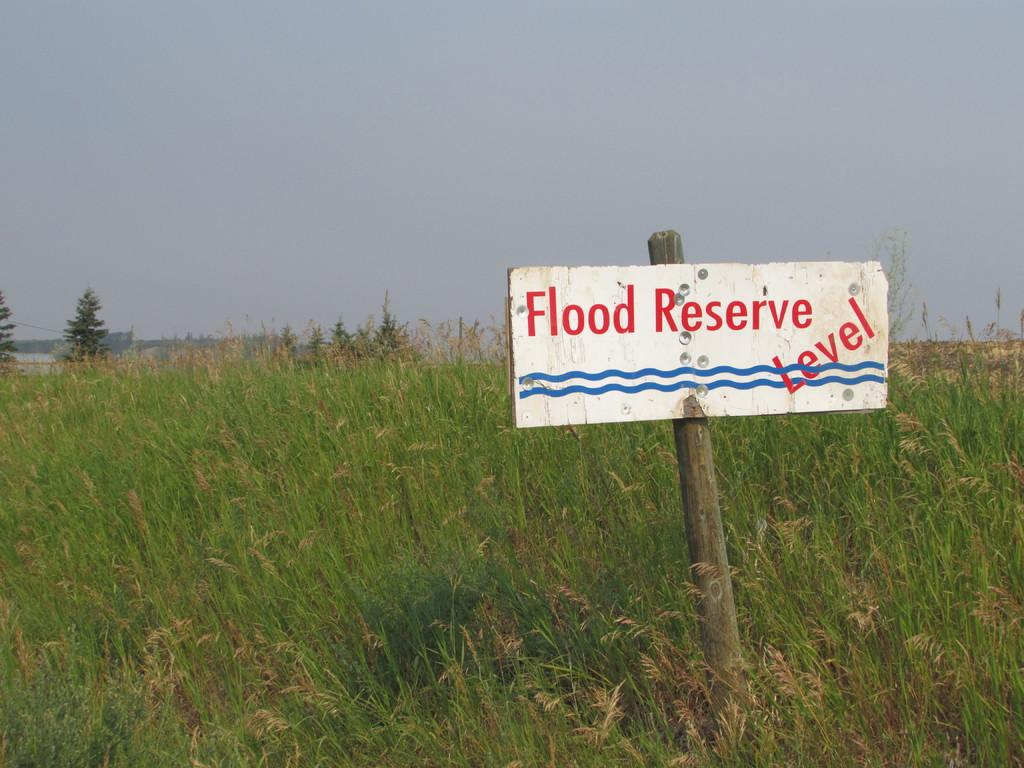What is the main object on the pole in the image? There is a board on a pole in the image. What type of vegetation can be seen in the image? There are plants and trees in the image. What is visible in the background of the image? The sky is visible in the background of the image. Where is the camera placed in the image? There is no camera present in the image. What does the mom say about the plants in the image? There is no mom present in the image, and therefore no commentary about the plants can be provided. 